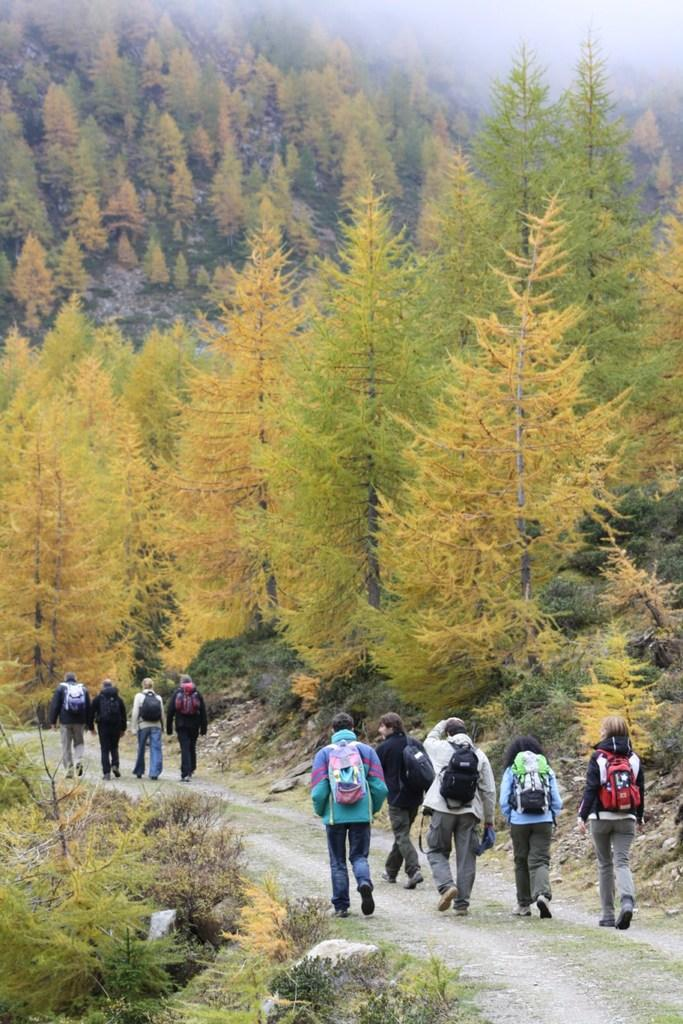What are the people in the image doing? The people in the image are walking. What are the people wearing on their bodies? The people are wearing bags. What is visible at the bottom of the image? There is ground visible at the bottom of the image. What can be seen in the distance in the image? There are trees in the background of the image. Can you tell me how many farmers are present in the image? There is no farmer present in the image; it features people walking while wearing bags. What type of wrist accessory is visible on the people in the image? There is no wrist accessory visible on the people in the image. 